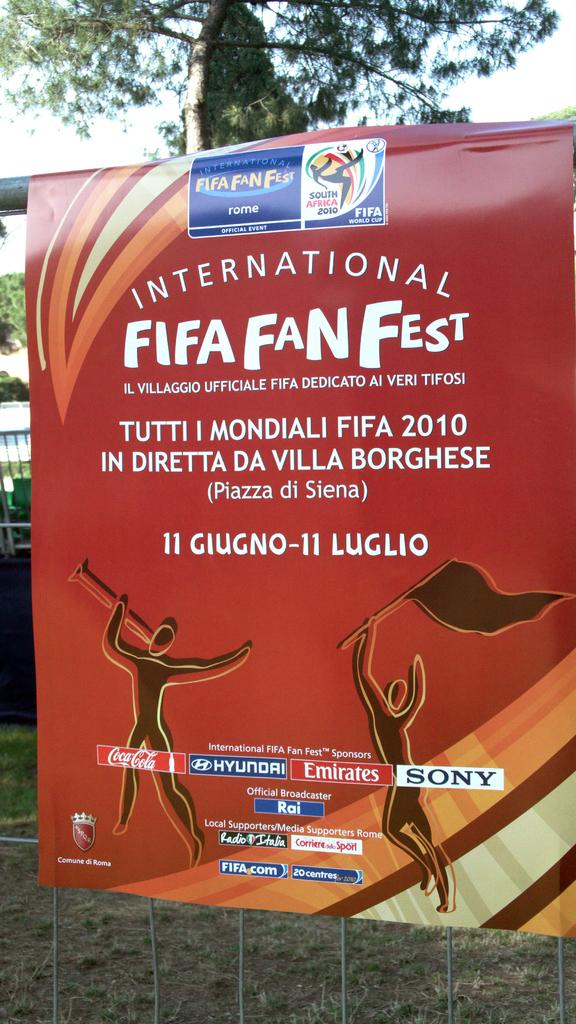<image>
Create a compact narrative representing the image presented. A red sign says International Fifa Fan Fest. 